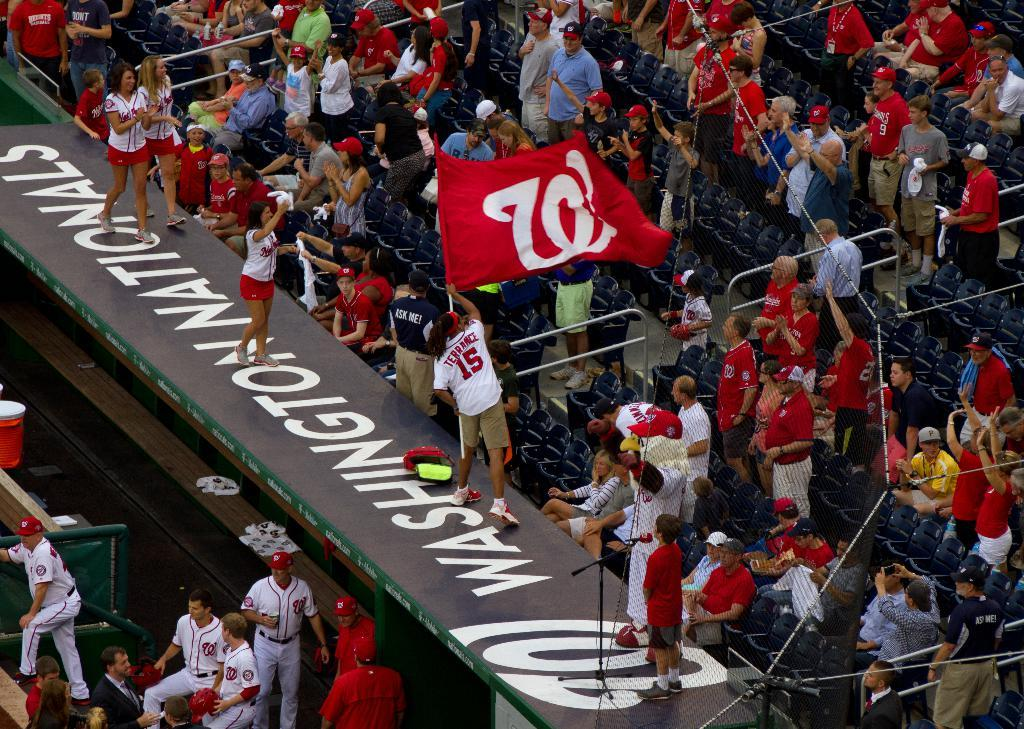Provide a one-sentence caption for the provided image. Washington Nationals contain people in the bleachers for a baseball game. 